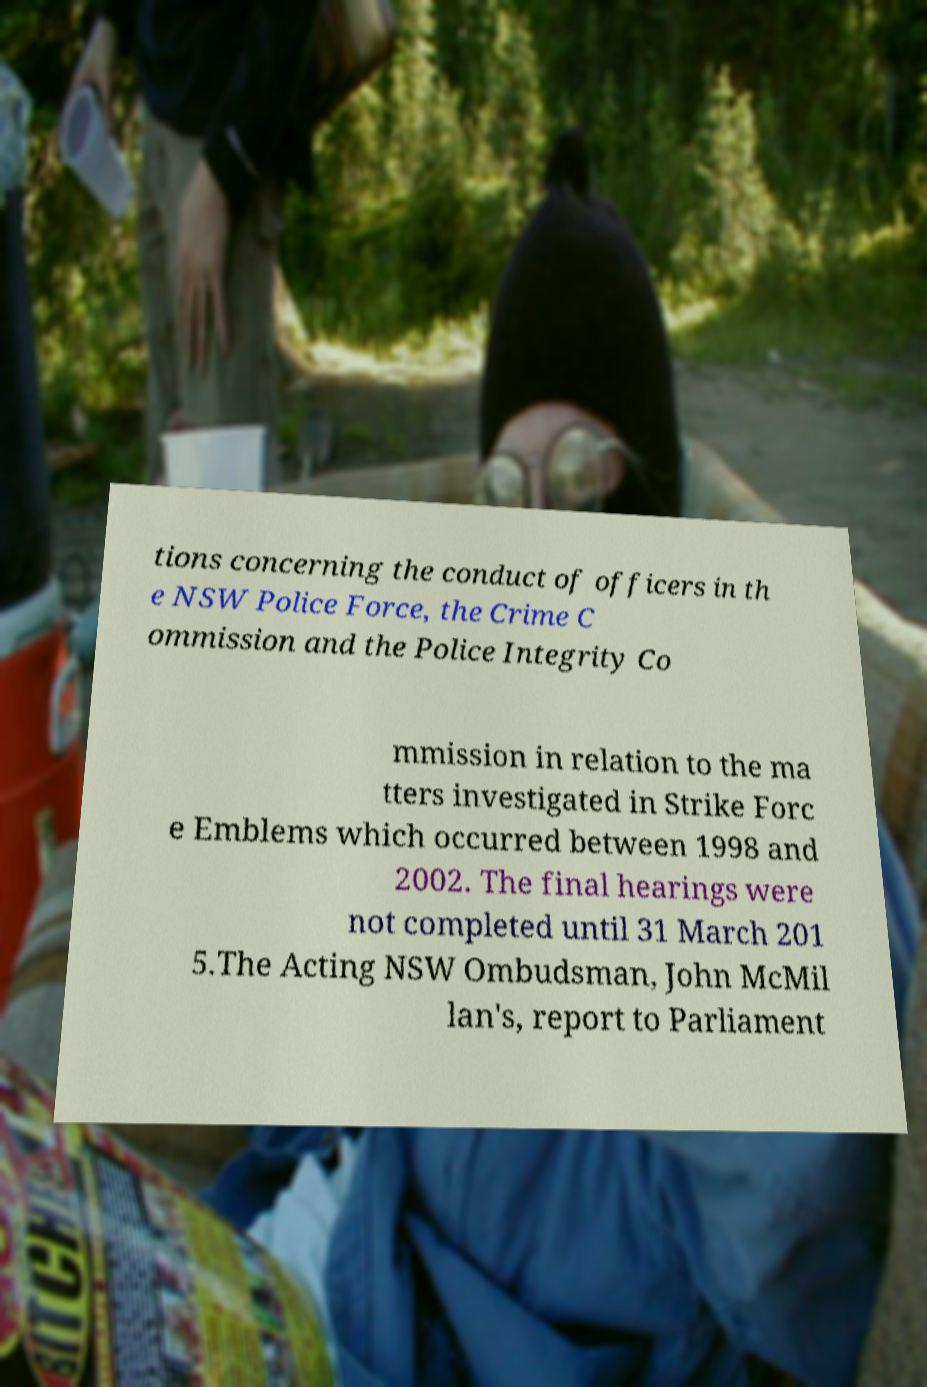Can you accurately transcribe the text from the provided image for me? tions concerning the conduct of officers in th e NSW Police Force, the Crime C ommission and the Police Integrity Co mmission in relation to the ma tters investigated in Strike Forc e Emblems which occurred between 1998 and 2002. The final hearings were not completed until 31 March 201 5.The Acting NSW Ombudsman, John McMil lan's, report to Parliament 